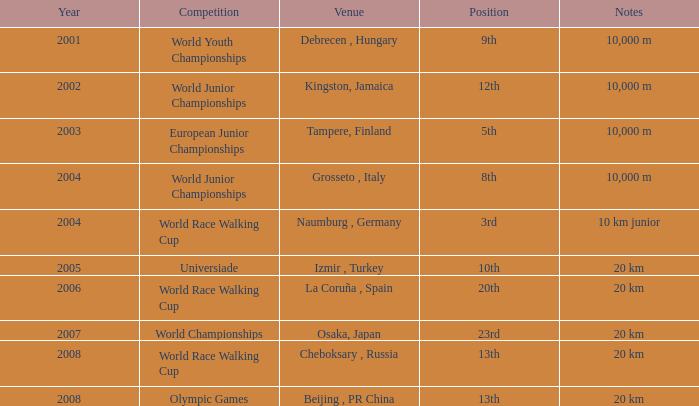In which year did he compete in the Universiade? 2005.0. 